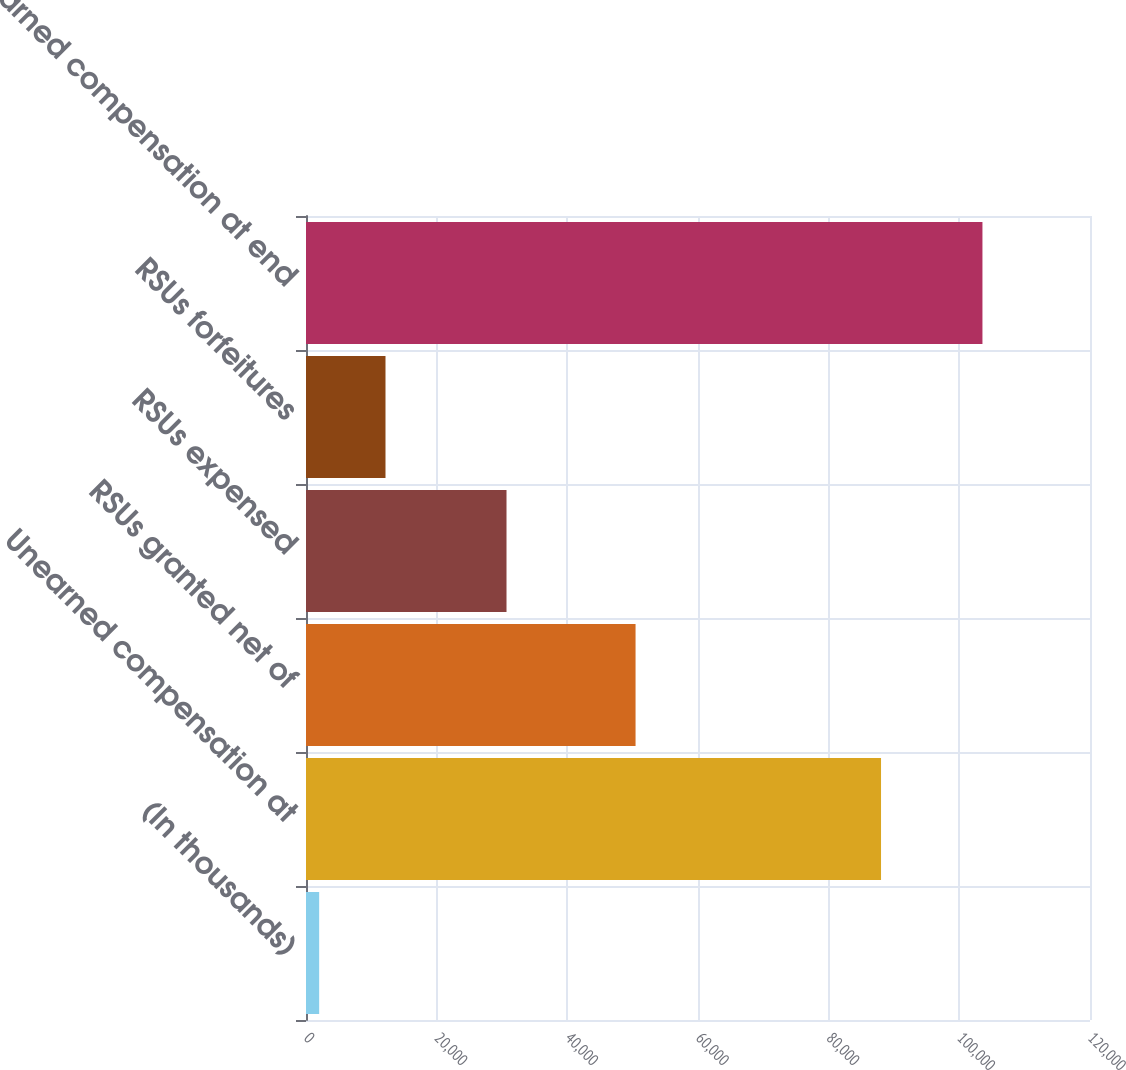Convert chart. <chart><loc_0><loc_0><loc_500><loc_500><bar_chart><fcel>(In thousands)<fcel>Unearned compensation at<fcel>RSUs granted net of<fcel>RSUs expensed<fcel>RSUs forfeitures<fcel>Unearned compensation at end<nl><fcel>2015<fcel>88015<fcel>50442<fcel>30691<fcel>12167.3<fcel>103538<nl></chart> 